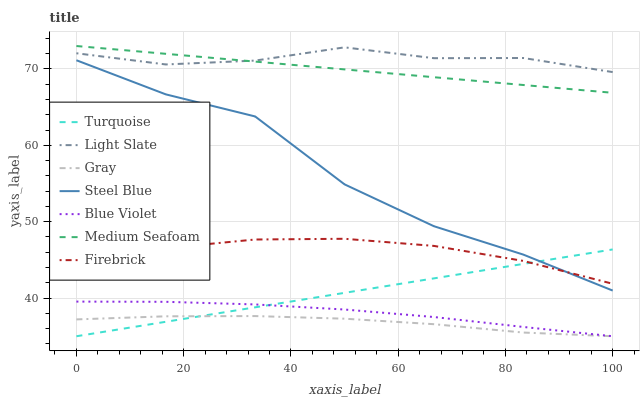Does Gray have the minimum area under the curve?
Answer yes or no. Yes. Does Light Slate have the maximum area under the curve?
Answer yes or no. Yes. Does Turquoise have the minimum area under the curve?
Answer yes or no. No. Does Turquoise have the maximum area under the curve?
Answer yes or no. No. Is Turquoise the smoothest?
Answer yes or no. Yes. Is Steel Blue the roughest?
Answer yes or no. Yes. Is Light Slate the smoothest?
Answer yes or no. No. Is Light Slate the roughest?
Answer yes or no. No. Does Gray have the lowest value?
Answer yes or no. Yes. Does Light Slate have the lowest value?
Answer yes or no. No. Does Medium Seafoam have the highest value?
Answer yes or no. Yes. Does Turquoise have the highest value?
Answer yes or no. No. Is Firebrick less than Medium Seafoam?
Answer yes or no. Yes. Is Firebrick greater than Blue Violet?
Answer yes or no. Yes. Does Turquoise intersect Gray?
Answer yes or no. Yes. Is Turquoise less than Gray?
Answer yes or no. No. Is Turquoise greater than Gray?
Answer yes or no. No. Does Firebrick intersect Medium Seafoam?
Answer yes or no. No. 